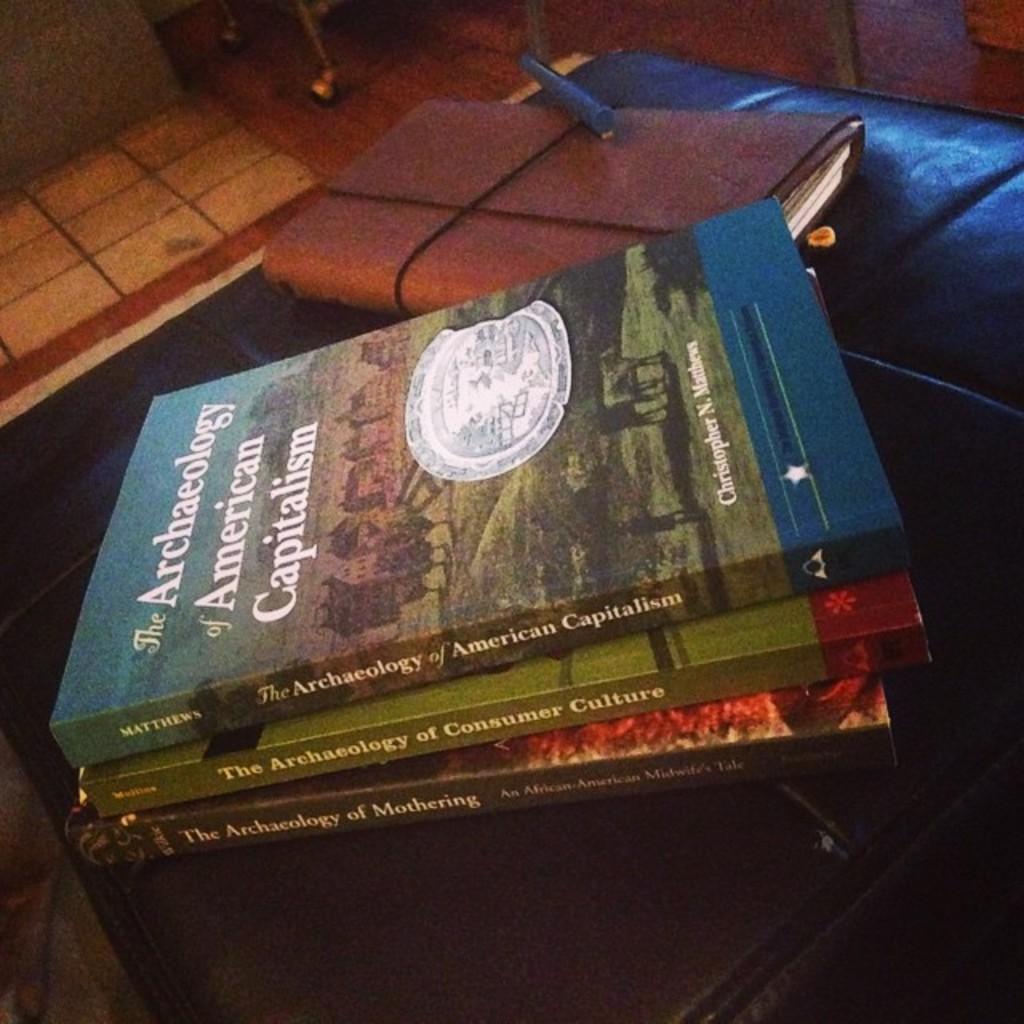What is the title of the book?
Ensure brevity in your answer.  The archaeology of american capitalism. 